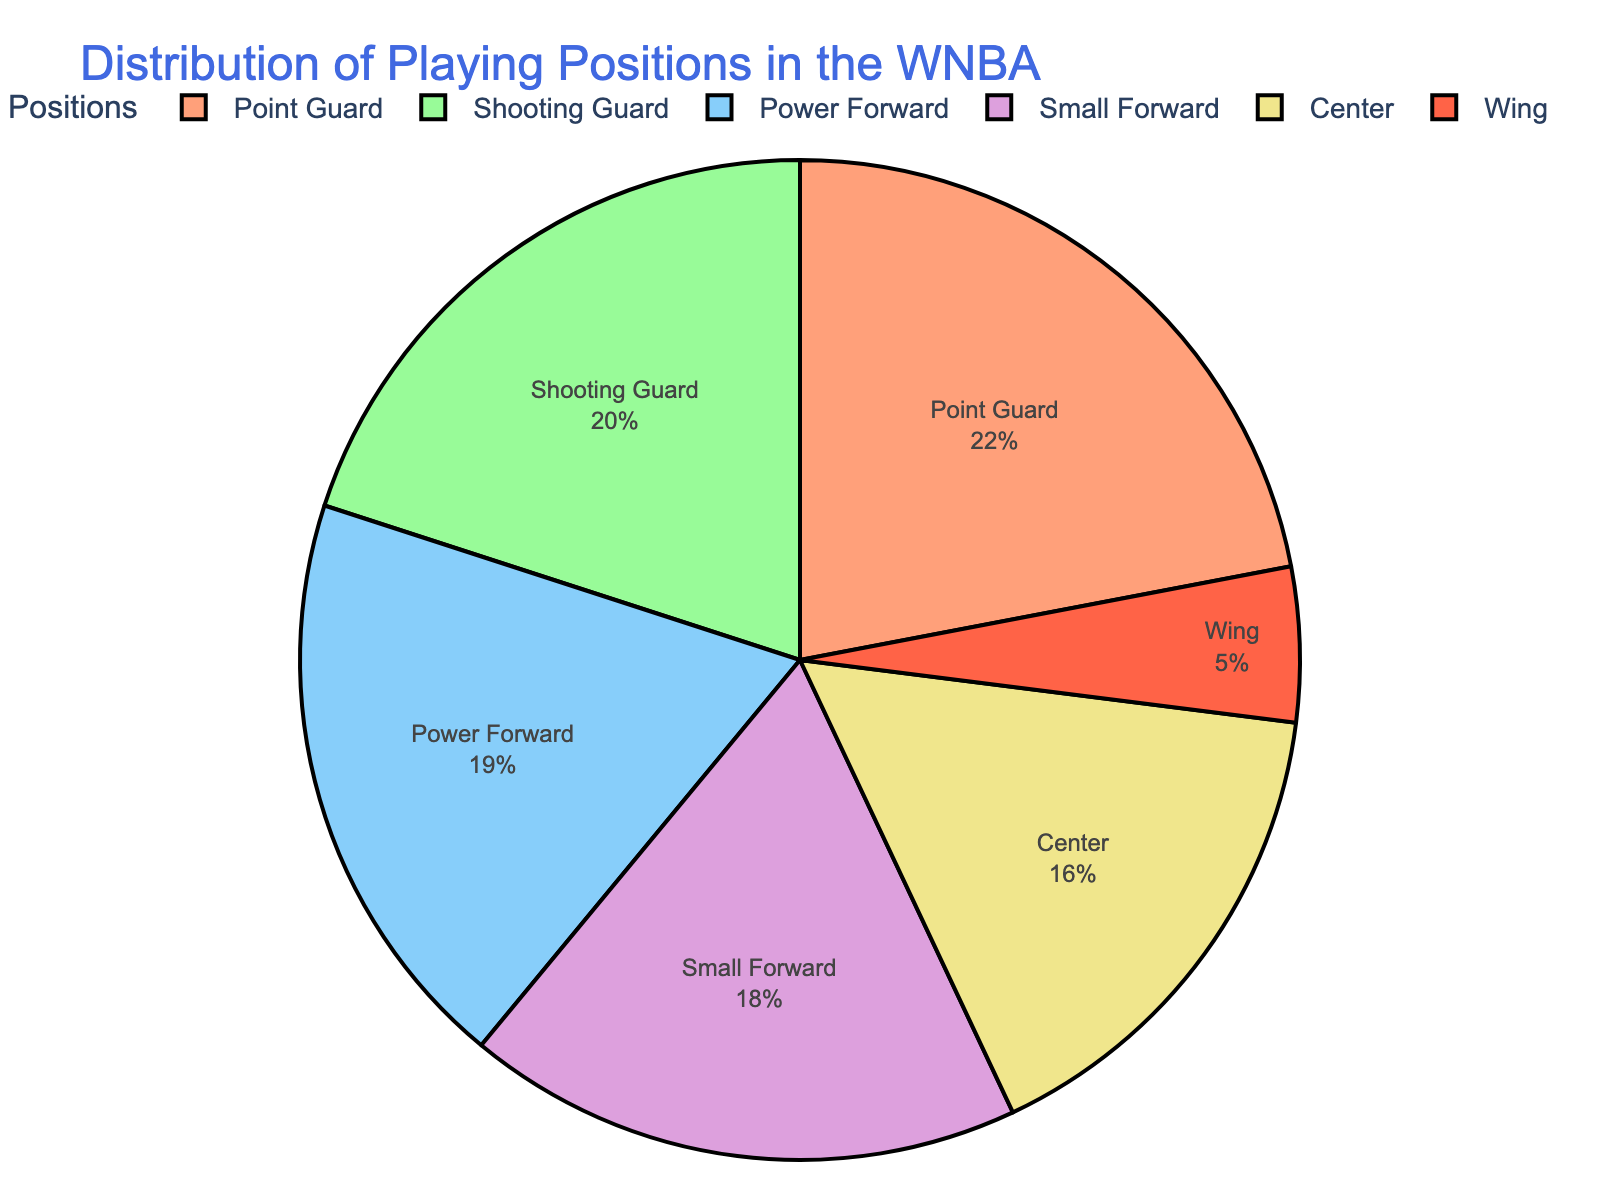What's the most common playing position in the WNBA? The playing position with the highest percentage represents the most common position. From the pie chart, the Point Guard position has the highest percentage at 22%.
Answer: Point Guard How much more common are Small Forwards than Centers in the WNBA? Compare the percentages of Small Forwards (18%) and Centers (16%) and subtract the latter from the former. The difference is 18% - 16% = 2%.
Answer: 2% Which playing position is the least common in the WNBA? The segment with the smallest percentage represents the least common position. The Wing position holds 5%, which is the lowest percentage in the pie chart.
Answer: Wing What is the combined percentage of Point Guards and Shooting Guards? Add the percentages for Point Guards (22%) and Shooting Guards (20%). The sum is 22% + 20% = 42%.
Answer: 42% Are there more Power Forwards or Small Forwards in the WNBA? Compare the percentages of Power Forwards (19%) and Small Forwards (18%). Power Forwards have 19%, which is more than the 18% of Small Forwards.
Answer: Power Forwards How much less common are Centers compared to the average percentage of all positions? First, find the average percentage of all positions by summing the percentages and dividing by the number of positions. The sum is 22% + 20% + 18% + 19% + 16% + 5% = 100%. The average is 100% / 6 = 16.67%. The difference between Centers (16%) and the average (16.67%) is 16.67% - 16% = 0.67%.
Answer: 0.67% Which position is represented using the yellow color in the pie chart? Look at the color legend and match it with the respective position percentage. The yellow-colored segment represents the Power Forward position.
Answer: Power Forward Among the Guard positions, which has a higher percentage and by how much? Compare the percentages of Point Guards (22%) and Shooting Guards (20%). The difference is 22% - 20% = 2%, with Point Guards being higher.
Answer: Point Guards by 2% If the Wing percentage doubled, what would it be? Multiply the current percentage of Wings (5%) by 2, resulting in 5% * 2 = 10%.
Answer: 10% 